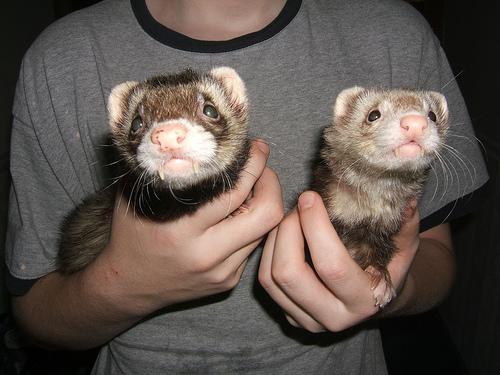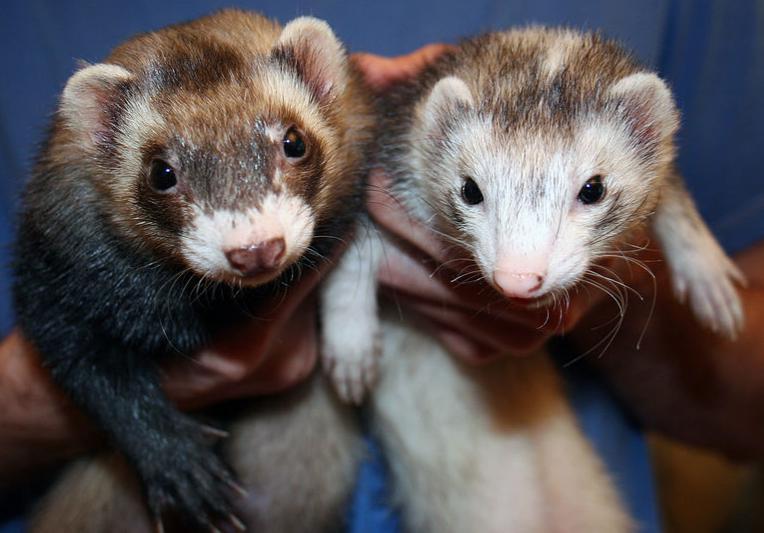The first image is the image on the left, the second image is the image on the right. Assess this claim about the two images: "Someone is holding at least one of the animals.". Correct or not? Answer yes or no. Yes. 